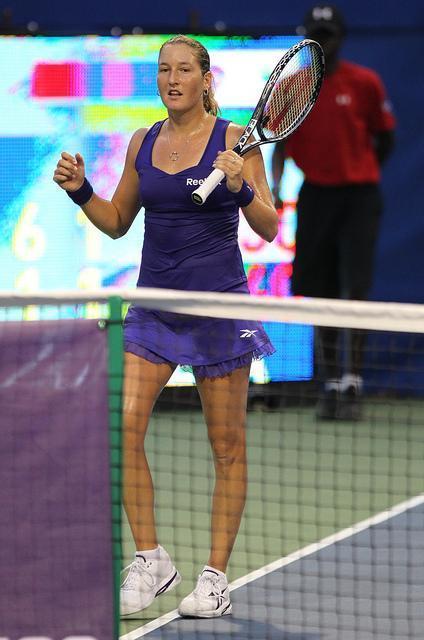How many people are visible?
Give a very brief answer. 2. 